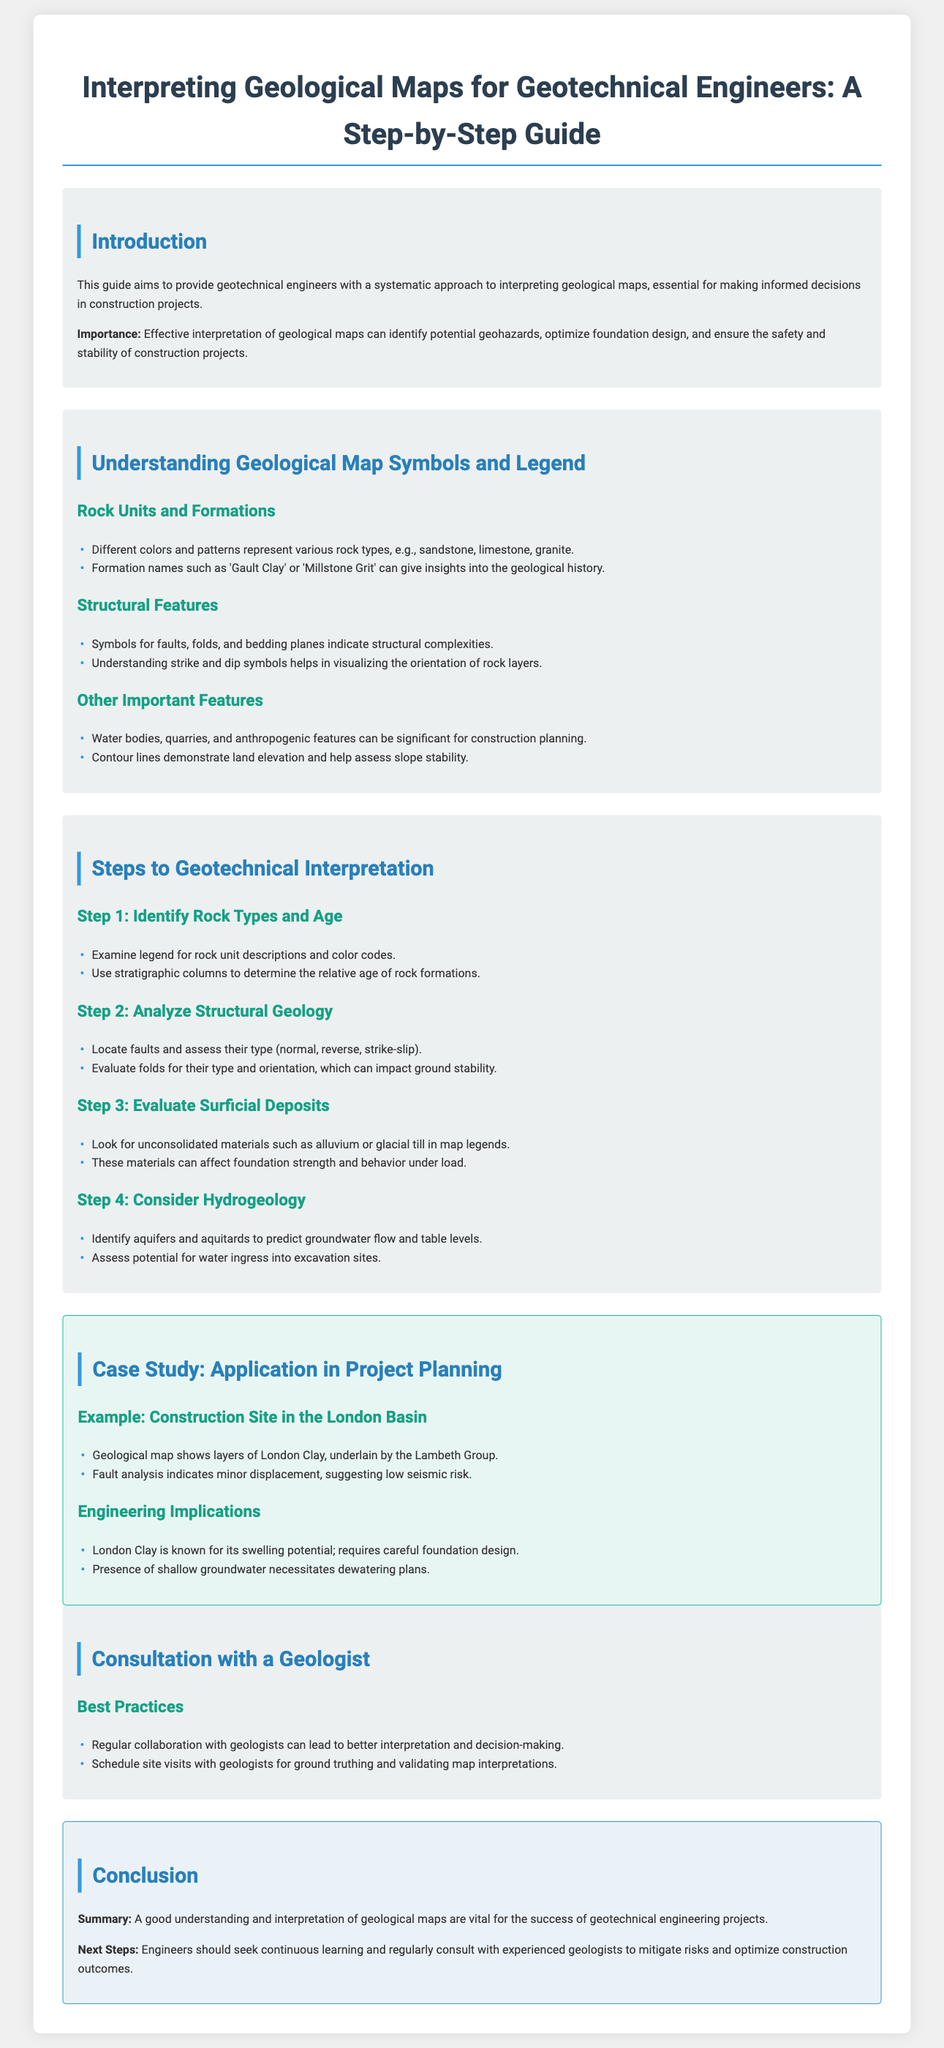what is the purpose of the guide? The guide aims to provide geotechnical engineers with a systematic approach to interpreting geological maps.
Answer: Systematic approach what does effective interpretation of geological maps identify? Effective interpretation can identify potential geohazards, optimize foundation design, and ensure safety and stability.
Answer: Potential geohazards what are the types of symbols for structural features on geological maps? Symbols for faults, folds, and bedding planes indicate structural complexities.
Answer: Faults, folds, bedding planes what is Step 1 in the geotechnical interpretation process? Step 1 is to identify rock types and age.
Answer: Identify rock types and age what layer is shown in the London Basin case study? The geological map shows layers of London Clay, underlain by the Lambeth Group.
Answer: London Clay what is an important consideration for foundation design in areas with London Clay? London Clay is known for its swelling potential; requires careful foundation design.
Answer: Swelling potential how can regular collaboration with geologists benefit engineers? Regular collaboration can lead to better interpretation and decision-making.
Answer: Better interpretation what is the next step suggested for engineers after understanding geological maps? Engineers should seek continuous learning and regularly consult with experienced geologists.
Answer: Continuous learning 